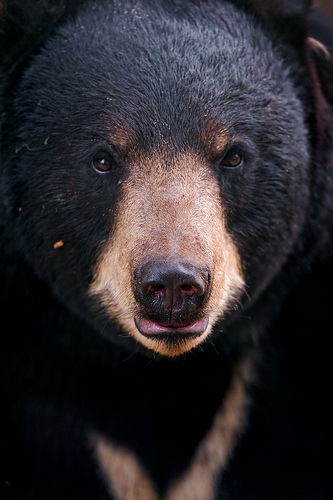Imagine this bear has a secret life as a superhero. Describe its superhero persona and powers. By day, this bear is a humble forest dweller, but by night it transforms into 'Shadowclaw,' a superhero with unmatched strength and agility. Shadowclaw has the power to blend seamlessly into dark environments, becoming nearly invisible. With heightened senses, it can detect danger from miles away and communicate with other forest animals telepathically. Its mission is to protect the forest from deforestation and to keep the ecosystem in balance, battling poachers and anyone who threatens the natural world. What kind of adventures might Shadowclaw have had? Shadowclaw's adventures are legendary among the forest creatures. One tale recounts the time Shadowclaw thwarted a group of poachers set on capturing animals for illegal trade. Using its invisibility, Shadowclaw stealthily dismantled their traps and led the poachers deep into the forest, where they were hopelessly lost and eventually captured by authorities. In another adventure, Shadowclaw united the forest animals to build a barrier against a devastating wildfire, using its telepathic communication to coordinate the efforts. Through these acts, Shadowclaw has become a beacon of hope and a symbol of resilience, ensuring the forest remains a haven for all its inhabitants. 